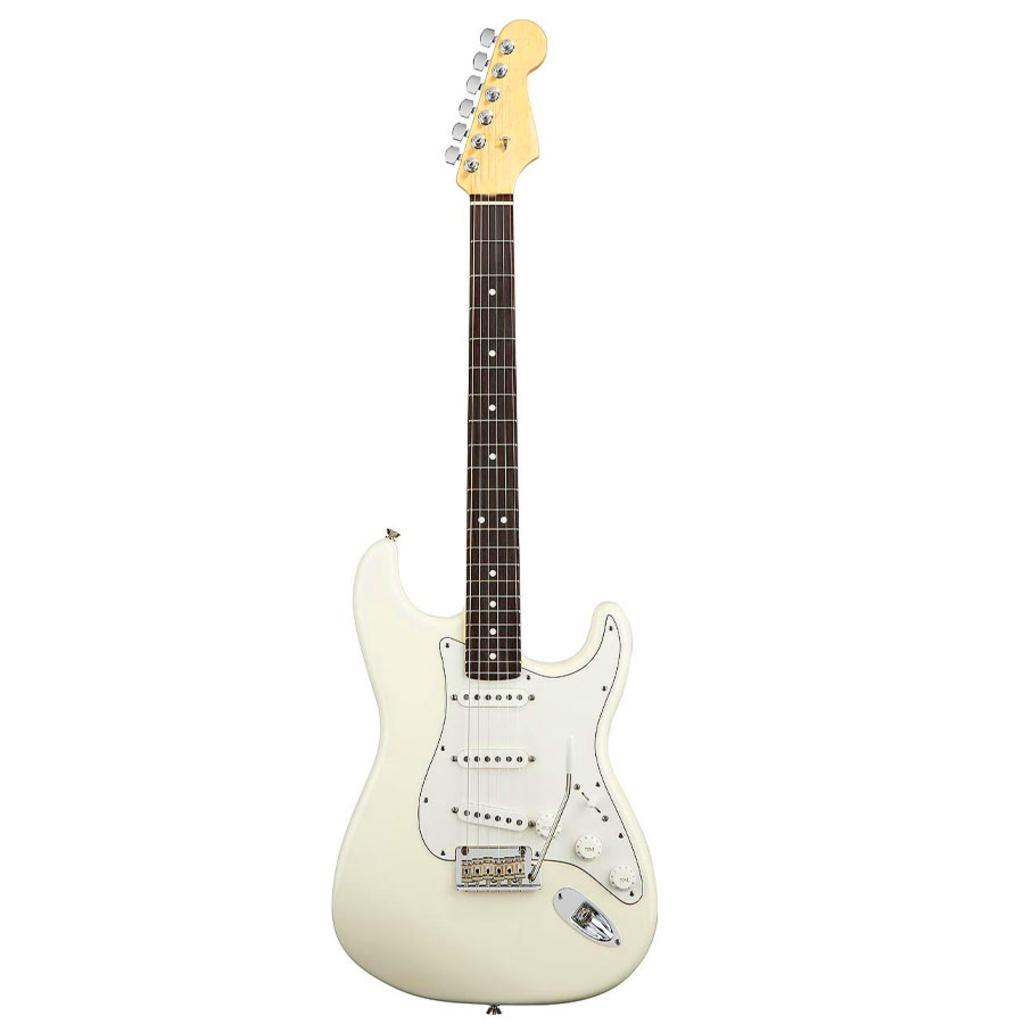What type of musical instrument is in the image? There is a white guitar in the image. Can you describe the color of the guitar? The guitar is white. How many baseballs can be seen on the guitar in the image? There are no baseballs present in the image; it features a white guitar. What type of animal might have a fang, and is it visible in the image? There is no animal with a fang visible in the image; it features a white guitar. 